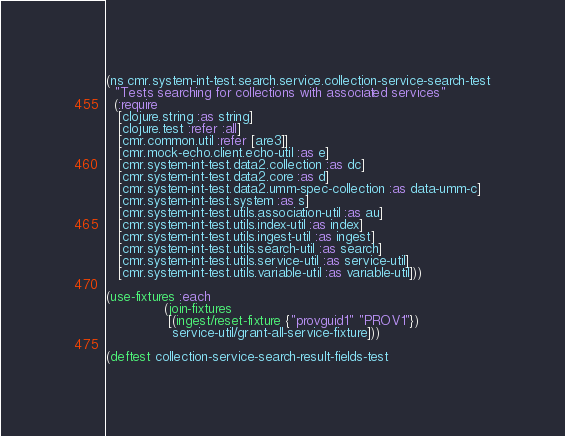<code> <loc_0><loc_0><loc_500><loc_500><_Clojure_>(ns cmr.system-int-test.search.service.collection-service-search-test
  "Tests searching for collections with associated services"
  (:require
   [clojure.string :as string]
   [clojure.test :refer :all]
   [cmr.common.util :refer [are3]]
   [cmr.mock-echo.client.echo-util :as e]
   [cmr.system-int-test.data2.collection :as dc]
   [cmr.system-int-test.data2.core :as d]
   [cmr.system-int-test.data2.umm-spec-collection :as data-umm-c]
   [cmr.system-int-test.system :as s]
   [cmr.system-int-test.utils.association-util :as au]
   [cmr.system-int-test.utils.index-util :as index]
   [cmr.system-int-test.utils.ingest-util :as ingest]
   [cmr.system-int-test.utils.search-util :as search]
   [cmr.system-int-test.utils.service-util :as service-util]
   [cmr.system-int-test.utils.variable-util :as variable-util]))

(use-fixtures :each
              (join-fixtures
               [(ingest/reset-fixture {"provguid1" "PROV1"})
                service-util/grant-all-service-fixture]))

(deftest collection-service-search-result-fields-test</code> 